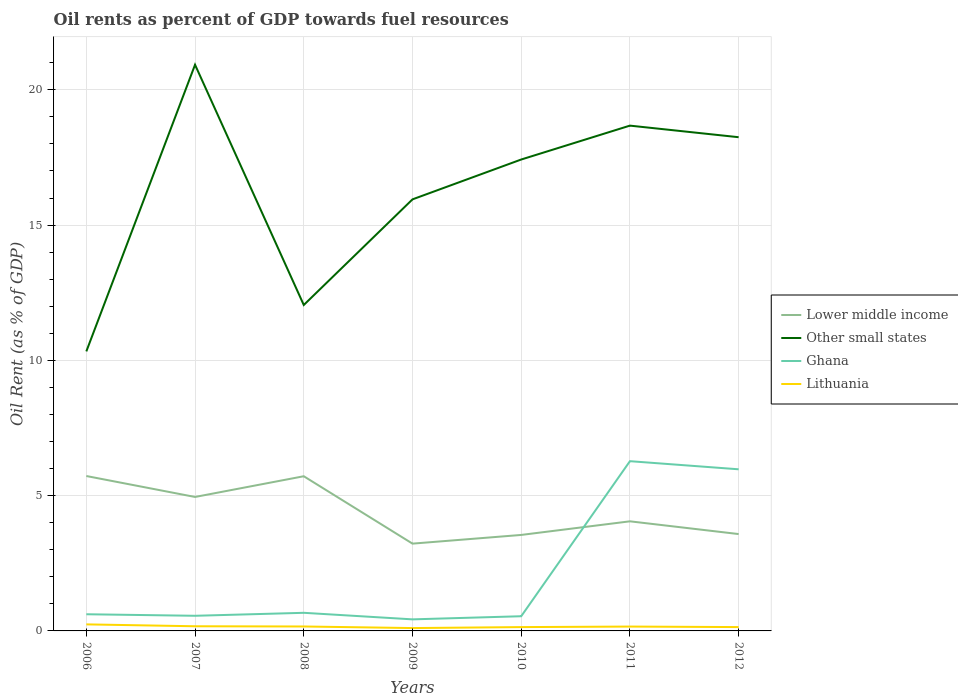Does the line corresponding to Lower middle income intersect with the line corresponding to Other small states?
Your response must be concise. No. Is the number of lines equal to the number of legend labels?
Keep it short and to the point. Yes. Across all years, what is the maximum oil rent in Other small states?
Your answer should be compact. 10.33. In which year was the oil rent in Other small states maximum?
Offer a very short reply. 2006. What is the total oil rent in Other small states in the graph?
Your response must be concise. 8.88. What is the difference between the highest and the second highest oil rent in Ghana?
Your response must be concise. 5.85. Is the oil rent in Lower middle income strictly greater than the oil rent in Ghana over the years?
Provide a succinct answer. No. How many lines are there?
Provide a succinct answer. 4. What is the difference between two consecutive major ticks on the Y-axis?
Offer a terse response. 5. Does the graph contain any zero values?
Provide a succinct answer. No. Where does the legend appear in the graph?
Your answer should be very brief. Center right. How many legend labels are there?
Your answer should be very brief. 4. What is the title of the graph?
Your response must be concise. Oil rents as percent of GDP towards fuel resources. What is the label or title of the X-axis?
Give a very brief answer. Years. What is the label or title of the Y-axis?
Ensure brevity in your answer.  Oil Rent (as % of GDP). What is the Oil Rent (as % of GDP) of Lower middle income in 2006?
Provide a short and direct response. 5.73. What is the Oil Rent (as % of GDP) of Other small states in 2006?
Keep it short and to the point. 10.33. What is the Oil Rent (as % of GDP) in Ghana in 2006?
Your response must be concise. 0.62. What is the Oil Rent (as % of GDP) of Lithuania in 2006?
Provide a succinct answer. 0.24. What is the Oil Rent (as % of GDP) of Lower middle income in 2007?
Make the answer very short. 4.95. What is the Oil Rent (as % of GDP) of Other small states in 2007?
Make the answer very short. 20.93. What is the Oil Rent (as % of GDP) in Ghana in 2007?
Make the answer very short. 0.56. What is the Oil Rent (as % of GDP) of Lithuania in 2007?
Your answer should be compact. 0.17. What is the Oil Rent (as % of GDP) of Lower middle income in 2008?
Offer a very short reply. 5.72. What is the Oil Rent (as % of GDP) in Other small states in 2008?
Ensure brevity in your answer.  12.05. What is the Oil Rent (as % of GDP) of Ghana in 2008?
Your response must be concise. 0.67. What is the Oil Rent (as % of GDP) in Lithuania in 2008?
Offer a terse response. 0.16. What is the Oil Rent (as % of GDP) in Lower middle income in 2009?
Provide a short and direct response. 3.23. What is the Oil Rent (as % of GDP) of Other small states in 2009?
Offer a very short reply. 15.95. What is the Oil Rent (as % of GDP) in Ghana in 2009?
Provide a short and direct response. 0.43. What is the Oil Rent (as % of GDP) in Lithuania in 2009?
Provide a short and direct response. 0.11. What is the Oil Rent (as % of GDP) in Lower middle income in 2010?
Make the answer very short. 3.55. What is the Oil Rent (as % of GDP) of Other small states in 2010?
Your response must be concise. 17.42. What is the Oil Rent (as % of GDP) of Ghana in 2010?
Your answer should be very brief. 0.54. What is the Oil Rent (as % of GDP) of Lithuania in 2010?
Offer a very short reply. 0.14. What is the Oil Rent (as % of GDP) of Lower middle income in 2011?
Offer a very short reply. 4.05. What is the Oil Rent (as % of GDP) in Other small states in 2011?
Give a very brief answer. 18.68. What is the Oil Rent (as % of GDP) in Ghana in 2011?
Provide a succinct answer. 6.27. What is the Oil Rent (as % of GDP) of Lithuania in 2011?
Give a very brief answer. 0.16. What is the Oil Rent (as % of GDP) in Lower middle income in 2012?
Your answer should be compact. 3.58. What is the Oil Rent (as % of GDP) in Other small states in 2012?
Make the answer very short. 18.25. What is the Oil Rent (as % of GDP) in Ghana in 2012?
Your answer should be compact. 5.97. What is the Oil Rent (as % of GDP) of Lithuania in 2012?
Your response must be concise. 0.14. Across all years, what is the maximum Oil Rent (as % of GDP) in Lower middle income?
Provide a short and direct response. 5.73. Across all years, what is the maximum Oil Rent (as % of GDP) in Other small states?
Make the answer very short. 20.93. Across all years, what is the maximum Oil Rent (as % of GDP) in Ghana?
Give a very brief answer. 6.27. Across all years, what is the maximum Oil Rent (as % of GDP) of Lithuania?
Your answer should be very brief. 0.24. Across all years, what is the minimum Oil Rent (as % of GDP) of Lower middle income?
Keep it short and to the point. 3.23. Across all years, what is the minimum Oil Rent (as % of GDP) in Other small states?
Ensure brevity in your answer.  10.33. Across all years, what is the minimum Oil Rent (as % of GDP) of Ghana?
Give a very brief answer. 0.43. Across all years, what is the minimum Oil Rent (as % of GDP) in Lithuania?
Provide a short and direct response. 0.11. What is the total Oil Rent (as % of GDP) of Lower middle income in the graph?
Your answer should be very brief. 30.8. What is the total Oil Rent (as % of GDP) in Other small states in the graph?
Your answer should be compact. 113.61. What is the total Oil Rent (as % of GDP) in Ghana in the graph?
Offer a very short reply. 15.06. What is the total Oil Rent (as % of GDP) in Lithuania in the graph?
Your answer should be compact. 1.13. What is the difference between the Oil Rent (as % of GDP) in Lower middle income in 2006 and that in 2007?
Give a very brief answer. 0.77. What is the difference between the Oil Rent (as % of GDP) in Other small states in 2006 and that in 2007?
Provide a succinct answer. -10.6. What is the difference between the Oil Rent (as % of GDP) in Ghana in 2006 and that in 2007?
Your response must be concise. 0.06. What is the difference between the Oil Rent (as % of GDP) of Lithuania in 2006 and that in 2007?
Offer a very short reply. 0.07. What is the difference between the Oil Rent (as % of GDP) in Lower middle income in 2006 and that in 2008?
Give a very brief answer. 0.01. What is the difference between the Oil Rent (as % of GDP) in Other small states in 2006 and that in 2008?
Provide a succinct answer. -1.72. What is the difference between the Oil Rent (as % of GDP) of Ghana in 2006 and that in 2008?
Make the answer very short. -0.05. What is the difference between the Oil Rent (as % of GDP) in Lithuania in 2006 and that in 2008?
Offer a very short reply. 0.08. What is the difference between the Oil Rent (as % of GDP) of Lower middle income in 2006 and that in 2009?
Provide a succinct answer. 2.5. What is the difference between the Oil Rent (as % of GDP) in Other small states in 2006 and that in 2009?
Your response must be concise. -5.62. What is the difference between the Oil Rent (as % of GDP) in Ghana in 2006 and that in 2009?
Your answer should be very brief. 0.19. What is the difference between the Oil Rent (as % of GDP) of Lithuania in 2006 and that in 2009?
Provide a succinct answer. 0.14. What is the difference between the Oil Rent (as % of GDP) in Lower middle income in 2006 and that in 2010?
Offer a very short reply. 2.18. What is the difference between the Oil Rent (as % of GDP) in Other small states in 2006 and that in 2010?
Provide a succinct answer. -7.09. What is the difference between the Oil Rent (as % of GDP) in Ghana in 2006 and that in 2010?
Keep it short and to the point. 0.07. What is the difference between the Oil Rent (as % of GDP) of Lithuania in 2006 and that in 2010?
Provide a succinct answer. 0.1. What is the difference between the Oil Rent (as % of GDP) of Lower middle income in 2006 and that in 2011?
Your answer should be compact. 1.67. What is the difference between the Oil Rent (as % of GDP) of Other small states in 2006 and that in 2011?
Give a very brief answer. -8.34. What is the difference between the Oil Rent (as % of GDP) in Ghana in 2006 and that in 2011?
Your answer should be very brief. -5.66. What is the difference between the Oil Rent (as % of GDP) of Lithuania in 2006 and that in 2011?
Give a very brief answer. 0.08. What is the difference between the Oil Rent (as % of GDP) in Lower middle income in 2006 and that in 2012?
Keep it short and to the point. 2.15. What is the difference between the Oil Rent (as % of GDP) in Other small states in 2006 and that in 2012?
Make the answer very short. -7.92. What is the difference between the Oil Rent (as % of GDP) in Ghana in 2006 and that in 2012?
Keep it short and to the point. -5.36. What is the difference between the Oil Rent (as % of GDP) of Lithuania in 2006 and that in 2012?
Provide a succinct answer. 0.1. What is the difference between the Oil Rent (as % of GDP) in Lower middle income in 2007 and that in 2008?
Your answer should be compact. -0.77. What is the difference between the Oil Rent (as % of GDP) in Other small states in 2007 and that in 2008?
Give a very brief answer. 8.88. What is the difference between the Oil Rent (as % of GDP) in Ghana in 2007 and that in 2008?
Keep it short and to the point. -0.11. What is the difference between the Oil Rent (as % of GDP) in Lithuania in 2007 and that in 2008?
Ensure brevity in your answer.  0.01. What is the difference between the Oil Rent (as % of GDP) of Lower middle income in 2007 and that in 2009?
Give a very brief answer. 1.73. What is the difference between the Oil Rent (as % of GDP) in Other small states in 2007 and that in 2009?
Offer a very short reply. 4.98. What is the difference between the Oil Rent (as % of GDP) of Ghana in 2007 and that in 2009?
Your response must be concise. 0.13. What is the difference between the Oil Rent (as % of GDP) in Lithuania in 2007 and that in 2009?
Your response must be concise. 0.07. What is the difference between the Oil Rent (as % of GDP) in Lower middle income in 2007 and that in 2010?
Offer a terse response. 1.4. What is the difference between the Oil Rent (as % of GDP) in Other small states in 2007 and that in 2010?
Provide a succinct answer. 3.5. What is the difference between the Oil Rent (as % of GDP) of Ghana in 2007 and that in 2010?
Keep it short and to the point. 0.02. What is the difference between the Oil Rent (as % of GDP) in Lithuania in 2007 and that in 2010?
Provide a short and direct response. 0.03. What is the difference between the Oil Rent (as % of GDP) of Lower middle income in 2007 and that in 2011?
Provide a short and direct response. 0.9. What is the difference between the Oil Rent (as % of GDP) of Other small states in 2007 and that in 2011?
Offer a terse response. 2.25. What is the difference between the Oil Rent (as % of GDP) of Ghana in 2007 and that in 2011?
Give a very brief answer. -5.71. What is the difference between the Oil Rent (as % of GDP) in Lithuania in 2007 and that in 2011?
Provide a short and direct response. 0.01. What is the difference between the Oil Rent (as % of GDP) in Lower middle income in 2007 and that in 2012?
Your response must be concise. 1.37. What is the difference between the Oil Rent (as % of GDP) of Other small states in 2007 and that in 2012?
Your response must be concise. 2.68. What is the difference between the Oil Rent (as % of GDP) in Ghana in 2007 and that in 2012?
Your response must be concise. -5.41. What is the difference between the Oil Rent (as % of GDP) in Lithuania in 2007 and that in 2012?
Give a very brief answer. 0.03. What is the difference between the Oil Rent (as % of GDP) of Lower middle income in 2008 and that in 2009?
Make the answer very short. 2.49. What is the difference between the Oil Rent (as % of GDP) of Other small states in 2008 and that in 2009?
Keep it short and to the point. -3.9. What is the difference between the Oil Rent (as % of GDP) in Ghana in 2008 and that in 2009?
Your answer should be compact. 0.24. What is the difference between the Oil Rent (as % of GDP) in Lithuania in 2008 and that in 2009?
Make the answer very short. 0.06. What is the difference between the Oil Rent (as % of GDP) in Lower middle income in 2008 and that in 2010?
Keep it short and to the point. 2.17. What is the difference between the Oil Rent (as % of GDP) in Other small states in 2008 and that in 2010?
Provide a short and direct response. -5.38. What is the difference between the Oil Rent (as % of GDP) of Ghana in 2008 and that in 2010?
Provide a short and direct response. 0.13. What is the difference between the Oil Rent (as % of GDP) in Lithuania in 2008 and that in 2010?
Give a very brief answer. 0.02. What is the difference between the Oil Rent (as % of GDP) in Lower middle income in 2008 and that in 2011?
Provide a succinct answer. 1.67. What is the difference between the Oil Rent (as % of GDP) in Other small states in 2008 and that in 2011?
Your answer should be compact. -6.63. What is the difference between the Oil Rent (as % of GDP) of Ghana in 2008 and that in 2011?
Provide a short and direct response. -5.6. What is the difference between the Oil Rent (as % of GDP) of Lithuania in 2008 and that in 2011?
Your answer should be very brief. 0. What is the difference between the Oil Rent (as % of GDP) of Lower middle income in 2008 and that in 2012?
Provide a succinct answer. 2.14. What is the difference between the Oil Rent (as % of GDP) of Other small states in 2008 and that in 2012?
Give a very brief answer. -6.2. What is the difference between the Oil Rent (as % of GDP) of Ghana in 2008 and that in 2012?
Keep it short and to the point. -5.3. What is the difference between the Oil Rent (as % of GDP) in Lithuania in 2008 and that in 2012?
Provide a short and direct response. 0.02. What is the difference between the Oil Rent (as % of GDP) in Lower middle income in 2009 and that in 2010?
Provide a short and direct response. -0.32. What is the difference between the Oil Rent (as % of GDP) in Other small states in 2009 and that in 2010?
Give a very brief answer. -1.47. What is the difference between the Oil Rent (as % of GDP) of Ghana in 2009 and that in 2010?
Your answer should be compact. -0.12. What is the difference between the Oil Rent (as % of GDP) in Lithuania in 2009 and that in 2010?
Provide a short and direct response. -0.04. What is the difference between the Oil Rent (as % of GDP) in Lower middle income in 2009 and that in 2011?
Make the answer very short. -0.82. What is the difference between the Oil Rent (as % of GDP) of Other small states in 2009 and that in 2011?
Ensure brevity in your answer.  -2.73. What is the difference between the Oil Rent (as % of GDP) of Ghana in 2009 and that in 2011?
Your answer should be very brief. -5.85. What is the difference between the Oil Rent (as % of GDP) in Lithuania in 2009 and that in 2011?
Provide a succinct answer. -0.06. What is the difference between the Oil Rent (as % of GDP) in Lower middle income in 2009 and that in 2012?
Ensure brevity in your answer.  -0.35. What is the difference between the Oil Rent (as % of GDP) in Other small states in 2009 and that in 2012?
Make the answer very short. -2.3. What is the difference between the Oil Rent (as % of GDP) of Ghana in 2009 and that in 2012?
Offer a very short reply. -5.55. What is the difference between the Oil Rent (as % of GDP) of Lithuania in 2009 and that in 2012?
Your answer should be very brief. -0.04. What is the difference between the Oil Rent (as % of GDP) in Lower middle income in 2010 and that in 2011?
Make the answer very short. -0.5. What is the difference between the Oil Rent (as % of GDP) in Other small states in 2010 and that in 2011?
Keep it short and to the point. -1.25. What is the difference between the Oil Rent (as % of GDP) of Ghana in 2010 and that in 2011?
Keep it short and to the point. -5.73. What is the difference between the Oil Rent (as % of GDP) of Lithuania in 2010 and that in 2011?
Your answer should be compact. -0.02. What is the difference between the Oil Rent (as % of GDP) of Lower middle income in 2010 and that in 2012?
Your answer should be very brief. -0.03. What is the difference between the Oil Rent (as % of GDP) of Other small states in 2010 and that in 2012?
Your answer should be compact. -0.82. What is the difference between the Oil Rent (as % of GDP) of Ghana in 2010 and that in 2012?
Offer a terse response. -5.43. What is the difference between the Oil Rent (as % of GDP) of Lithuania in 2010 and that in 2012?
Offer a terse response. -0. What is the difference between the Oil Rent (as % of GDP) of Lower middle income in 2011 and that in 2012?
Provide a short and direct response. 0.47. What is the difference between the Oil Rent (as % of GDP) in Other small states in 2011 and that in 2012?
Make the answer very short. 0.43. What is the difference between the Oil Rent (as % of GDP) in Lithuania in 2011 and that in 2012?
Give a very brief answer. 0.02. What is the difference between the Oil Rent (as % of GDP) of Lower middle income in 2006 and the Oil Rent (as % of GDP) of Other small states in 2007?
Your response must be concise. -15.2. What is the difference between the Oil Rent (as % of GDP) in Lower middle income in 2006 and the Oil Rent (as % of GDP) in Ghana in 2007?
Your answer should be compact. 5.17. What is the difference between the Oil Rent (as % of GDP) of Lower middle income in 2006 and the Oil Rent (as % of GDP) of Lithuania in 2007?
Give a very brief answer. 5.55. What is the difference between the Oil Rent (as % of GDP) in Other small states in 2006 and the Oil Rent (as % of GDP) in Ghana in 2007?
Provide a short and direct response. 9.77. What is the difference between the Oil Rent (as % of GDP) in Other small states in 2006 and the Oil Rent (as % of GDP) in Lithuania in 2007?
Give a very brief answer. 10.16. What is the difference between the Oil Rent (as % of GDP) in Ghana in 2006 and the Oil Rent (as % of GDP) in Lithuania in 2007?
Your answer should be compact. 0.44. What is the difference between the Oil Rent (as % of GDP) in Lower middle income in 2006 and the Oil Rent (as % of GDP) in Other small states in 2008?
Give a very brief answer. -6.32. What is the difference between the Oil Rent (as % of GDP) in Lower middle income in 2006 and the Oil Rent (as % of GDP) in Ghana in 2008?
Your answer should be compact. 5.06. What is the difference between the Oil Rent (as % of GDP) in Lower middle income in 2006 and the Oil Rent (as % of GDP) in Lithuania in 2008?
Your answer should be compact. 5.56. What is the difference between the Oil Rent (as % of GDP) of Other small states in 2006 and the Oil Rent (as % of GDP) of Ghana in 2008?
Offer a terse response. 9.66. What is the difference between the Oil Rent (as % of GDP) of Other small states in 2006 and the Oil Rent (as % of GDP) of Lithuania in 2008?
Your answer should be compact. 10.17. What is the difference between the Oil Rent (as % of GDP) in Ghana in 2006 and the Oil Rent (as % of GDP) in Lithuania in 2008?
Give a very brief answer. 0.45. What is the difference between the Oil Rent (as % of GDP) in Lower middle income in 2006 and the Oil Rent (as % of GDP) in Other small states in 2009?
Your response must be concise. -10.23. What is the difference between the Oil Rent (as % of GDP) in Lower middle income in 2006 and the Oil Rent (as % of GDP) in Ghana in 2009?
Your response must be concise. 5.3. What is the difference between the Oil Rent (as % of GDP) in Lower middle income in 2006 and the Oil Rent (as % of GDP) in Lithuania in 2009?
Your answer should be very brief. 5.62. What is the difference between the Oil Rent (as % of GDP) of Other small states in 2006 and the Oil Rent (as % of GDP) of Ghana in 2009?
Ensure brevity in your answer.  9.9. What is the difference between the Oil Rent (as % of GDP) in Other small states in 2006 and the Oil Rent (as % of GDP) in Lithuania in 2009?
Provide a short and direct response. 10.23. What is the difference between the Oil Rent (as % of GDP) in Ghana in 2006 and the Oil Rent (as % of GDP) in Lithuania in 2009?
Keep it short and to the point. 0.51. What is the difference between the Oil Rent (as % of GDP) of Lower middle income in 2006 and the Oil Rent (as % of GDP) of Other small states in 2010?
Ensure brevity in your answer.  -11.7. What is the difference between the Oil Rent (as % of GDP) of Lower middle income in 2006 and the Oil Rent (as % of GDP) of Ghana in 2010?
Provide a short and direct response. 5.18. What is the difference between the Oil Rent (as % of GDP) in Lower middle income in 2006 and the Oil Rent (as % of GDP) in Lithuania in 2010?
Ensure brevity in your answer.  5.58. What is the difference between the Oil Rent (as % of GDP) of Other small states in 2006 and the Oil Rent (as % of GDP) of Ghana in 2010?
Your answer should be compact. 9.79. What is the difference between the Oil Rent (as % of GDP) of Other small states in 2006 and the Oil Rent (as % of GDP) of Lithuania in 2010?
Your response must be concise. 10.19. What is the difference between the Oil Rent (as % of GDP) in Ghana in 2006 and the Oil Rent (as % of GDP) in Lithuania in 2010?
Your response must be concise. 0.47. What is the difference between the Oil Rent (as % of GDP) of Lower middle income in 2006 and the Oil Rent (as % of GDP) of Other small states in 2011?
Give a very brief answer. -12.95. What is the difference between the Oil Rent (as % of GDP) of Lower middle income in 2006 and the Oil Rent (as % of GDP) of Ghana in 2011?
Give a very brief answer. -0.55. What is the difference between the Oil Rent (as % of GDP) in Lower middle income in 2006 and the Oil Rent (as % of GDP) in Lithuania in 2011?
Provide a succinct answer. 5.56. What is the difference between the Oil Rent (as % of GDP) in Other small states in 2006 and the Oil Rent (as % of GDP) in Ghana in 2011?
Give a very brief answer. 4.06. What is the difference between the Oil Rent (as % of GDP) of Other small states in 2006 and the Oil Rent (as % of GDP) of Lithuania in 2011?
Your response must be concise. 10.17. What is the difference between the Oil Rent (as % of GDP) of Ghana in 2006 and the Oil Rent (as % of GDP) of Lithuania in 2011?
Ensure brevity in your answer.  0.46. What is the difference between the Oil Rent (as % of GDP) of Lower middle income in 2006 and the Oil Rent (as % of GDP) of Other small states in 2012?
Give a very brief answer. -12.52. What is the difference between the Oil Rent (as % of GDP) of Lower middle income in 2006 and the Oil Rent (as % of GDP) of Ghana in 2012?
Provide a short and direct response. -0.25. What is the difference between the Oil Rent (as % of GDP) of Lower middle income in 2006 and the Oil Rent (as % of GDP) of Lithuania in 2012?
Provide a short and direct response. 5.58. What is the difference between the Oil Rent (as % of GDP) of Other small states in 2006 and the Oil Rent (as % of GDP) of Ghana in 2012?
Make the answer very short. 4.36. What is the difference between the Oil Rent (as % of GDP) in Other small states in 2006 and the Oil Rent (as % of GDP) in Lithuania in 2012?
Ensure brevity in your answer.  10.19. What is the difference between the Oil Rent (as % of GDP) in Ghana in 2006 and the Oil Rent (as % of GDP) in Lithuania in 2012?
Your response must be concise. 0.47. What is the difference between the Oil Rent (as % of GDP) of Lower middle income in 2007 and the Oil Rent (as % of GDP) of Other small states in 2008?
Give a very brief answer. -7.1. What is the difference between the Oil Rent (as % of GDP) of Lower middle income in 2007 and the Oil Rent (as % of GDP) of Ghana in 2008?
Ensure brevity in your answer.  4.28. What is the difference between the Oil Rent (as % of GDP) in Lower middle income in 2007 and the Oil Rent (as % of GDP) in Lithuania in 2008?
Give a very brief answer. 4.79. What is the difference between the Oil Rent (as % of GDP) of Other small states in 2007 and the Oil Rent (as % of GDP) of Ghana in 2008?
Give a very brief answer. 20.26. What is the difference between the Oil Rent (as % of GDP) in Other small states in 2007 and the Oil Rent (as % of GDP) in Lithuania in 2008?
Provide a short and direct response. 20.76. What is the difference between the Oil Rent (as % of GDP) of Ghana in 2007 and the Oil Rent (as % of GDP) of Lithuania in 2008?
Provide a short and direct response. 0.4. What is the difference between the Oil Rent (as % of GDP) of Lower middle income in 2007 and the Oil Rent (as % of GDP) of Ghana in 2009?
Make the answer very short. 4.52. What is the difference between the Oil Rent (as % of GDP) in Lower middle income in 2007 and the Oil Rent (as % of GDP) in Lithuania in 2009?
Offer a very short reply. 4.85. What is the difference between the Oil Rent (as % of GDP) of Other small states in 2007 and the Oil Rent (as % of GDP) of Ghana in 2009?
Offer a very short reply. 20.5. What is the difference between the Oil Rent (as % of GDP) of Other small states in 2007 and the Oil Rent (as % of GDP) of Lithuania in 2009?
Provide a succinct answer. 20.82. What is the difference between the Oil Rent (as % of GDP) in Ghana in 2007 and the Oil Rent (as % of GDP) in Lithuania in 2009?
Provide a short and direct response. 0.45. What is the difference between the Oil Rent (as % of GDP) of Lower middle income in 2007 and the Oil Rent (as % of GDP) of Other small states in 2010?
Your response must be concise. -12.47. What is the difference between the Oil Rent (as % of GDP) in Lower middle income in 2007 and the Oil Rent (as % of GDP) in Ghana in 2010?
Ensure brevity in your answer.  4.41. What is the difference between the Oil Rent (as % of GDP) of Lower middle income in 2007 and the Oil Rent (as % of GDP) of Lithuania in 2010?
Provide a succinct answer. 4.81. What is the difference between the Oil Rent (as % of GDP) of Other small states in 2007 and the Oil Rent (as % of GDP) of Ghana in 2010?
Keep it short and to the point. 20.38. What is the difference between the Oil Rent (as % of GDP) in Other small states in 2007 and the Oil Rent (as % of GDP) in Lithuania in 2010?
Make the answer very short. 20.79. What is the difference between the Oil Rent (as % of GDP) in Ghana in 2007 and the Oil Rent (as % of GDP) in Lithuania in 2010?
Give a very brief answer. 0.42. What is the difference between the Oil Rent (as % of GDP) of Lower middle income in 2007 and the Oil Rent (as % of GDP) of Other small states in 2011?
Provide a short and direct response. -13.73. What is the difference between the Oil Rent (as % of GDP) in Lower middle income in 2007 and the Oil Rent (as % of GDP) in Ghana in 2011?
Offer a very short reply. -1.32. What is the difference between the Oil Rent (as % of GDP) in Lower middle income in 2007 and the Oil Rent (as % of GDP) in Lithuania in 2011?
Provide a succinct answer. 4.79. What is the difference between the Oil Rent (as % of GDP) of Other small states in 2007 and the Oil Rent (as % of GDP) of Ghana in 2011?
Provide a succinct answer. 14.65. What is the difference between the Oil Rent (as % of GDP) in Other small states in 2007 and the Oil Rent (as % of GDP) in Lithuania in 2011?
Provide a short and direct response. 20.77. What is the difference between the Oil Rent (as % of GDP) of Ghana in 2007 and the Oil Rent (as % of GDP) of Lithuania in 2011?
Your answer should be compact. 0.4. What is the difference between the Oil Rent (as % of GDP) of Lower middle income in 2007 and the Oil Rent (as % of GDP) of Other small states in 2012?
Your answer should be compact. -13.3. What is the difference between the Oil Rent (as % of GDP) of Lower middle income in 2007 and the Oil Rent (as % of GDP) of Ghana in 2012?
Offer a very short reply. -1.02. What is the difference between the Oil Rent (as % of GDP) of Lower middle income in 2007 and the Oil Rent (as % of GDP) of Lithuania in 2012?
Offer a very short reply. 4.81. What is the difference between the Oil Rent (as % of GDP) in Other small states in 2007 and the Oil Rent (as % of GDP) in Ghana in 2012?
Provide a short and direct response. 14.95. What is the difference between the Oil Rent (as % of GDP) in Other small states in 2007 and the Oil Rent (as % of GDP) in Lithuania in 2012?
Your answer should be compact. 20.79. What is the difference between the Oil Rent (as % of GDP) of Ghana in 2007 and the Oil Rent (as % of GDP) of Lithuania in 2012?
Make the answer very short. 0.42. What is the difference between the Oil Rent (as % of GDP) in Lower middle income in 2008 and the Oil Rent (as % of GDP) in Other small states in 2009?
Offer a terse response. -10.23. What is the difference between the Oil Rent (as % of GDP) in Lower middle income in 2008 and the Oil Rent (as % of GDP) in Ghana in 2009?
Ensure brevity in your answer.  5.29. What is the difference between the Oil Rent (as % of GDP) of Lower middle income in 2008 and the Oil Rent (as % of GDP) of Lithuania in 2009?
Offer a terse response. 5.61. What is the difference between the Oil Rent (as % of GDP) in Other small states in 2008 and the Oil Rent (as % of GDP) in Ghana in 2009?
Provide a succinct answer. 11.62. What is the difference between the Oil Rent (as % of GDP) of Other small states in 2008 and the Oil Rent (as % of GDP) of Lithuania in 2009?
Make the answer very short. 11.94. What is the difference between the Oil Rent (as % of GDP) in Ghana in 2008 and the Oil Rent (as % of GDP) in Lithuania in 2009?
Make the answer very short. 0.56. What is the difference between the Oil Rent (as % of GDP) in Lower middle income in 2008 and the Oil Rent (as % of GDP) in Other small states in 2010?
Provide a short and direct response. -11.71. What is the difference between the Oil Rent (as % of GDP) of Lower middle income in 2008 and the Oil Rent (as % of GDP) of Ghana in 2010?
Keep it short and to the point. 5.17. What is the difference between the Oil Rent (as % of GDP) in Lower middle income in 2008 and the Oil Rent (as % of GDP) in Lithuania in 2010?
Provide a short and direct response. 5.58. What is the difference between the Oil Rent (as % of GDP) of Other small states in 2008 and the Oil Rent (as % of GDP) of Ghana in 2010?
Your answer should be very brief. 11.5. What is the difference between the Oil Rent (as % of GDP) in Other small states in 2008 and the Oil Rent (as % of GDP) in Lithuania in 2010?
Keep it short and to the point. 11.91. What is the difference between the Oil Rent (as % of GDP) of Ghana in 2008 and the Oil Rent (as % of GDP) of Lithuania in 2010?
Your answer should be very brief. 0.53. What is the difference between the Oil Rent (as % of GDP) of Lower middle income in 2008 and the Oil Rent (as % of GDP) of Other small states in 2011?
Your answer should be very brief. -12.96. What is the difference between the Oil Rent (as % of GDP) of Lower middle income in 2008 and the Oil Rent (as % of GDP) of Ghana in 2011?
Provide a succinct answer. -0.56. What is the difference between the Oil Rent (as % of GDP) in Lower middle income in 2008 and the Oil Rent (as % of GDP) in Lithuania in 2011?
Ensure brevity in your answer.  5.56. What is the difference between the Oil Rent (as % of GDP) of Other small states in 2008 and the Oil Rent (as % of GDP) of Ghana in 2011?
Make the answer very short. 5.77. What is the difference between the Oil Rent (as % of GDP) of Other small states in 2008 and the Oil Rent (as % of GDP) of Lithuania in 2011?
Provide a succinct answer. 11.89. What is the difference between the Oil Rent (as % of GDP) in Ghana in 2008 and the Oil Rent (as % of GDP) in Lithuania in 2011?
Give a very brief answer. 0.51. What is the difference between the Oil Rent (as % of GDP) of Lower middle income in 2008 and the Oil Rent (as % of GDP) of Other small states in 2012?
Your answer should be very brief. -12.53. What is the difference between the Oil Rent (as % of GDP) of Lower middle income in 2008 and the Oil Rent (as % of GDP) of Ghana in 2012?
Offer a very short reply. -0.26. What is the difference between the Oil Rent (as % of GDP) of Lower middle income in 2008 and the Oil Rent (as % of GDP) of Lithuania in 2012?
Provide a succinct answer. 5.58. What is the difference between the Oil Rent (as % of GDP) of Other small states in 2008 and the Oil Rent (as % of GDP) of Ghana in 2012?
Your response must be concise. 6.07. What is the difference between the Oil Rent (as % of GDP) in Other small states in 2008 and the Oil Rent (as % of GDP) in Lithuania in 2012?
Provide a short and direct response. 11.9. What is the difference between the Oil Rent (as % of GDP) of Ghana in 2008 and the Oil Rent (as % of GDP) of Lithuania in 2012?
Your answer should be very brief. 0.53. What is the difference between the Oil Rent (as % of GDP) in Lower middle income in 2009 and the Oil Rent (as % of GDP) in Other small states in 2010?
Keep it short and to the point. -14.2. What is the difference between the Oil Rent (as % of GDP) of Lower middle income in 2009 and the Oil Rent (as % of GDP) of Ghana in 2010?
Give a very brief answer. 2.68. What is the difference between the Oil Rent (as % of GDP) of Lower middle income in 2009 and the Oil Rent (as % of GDP) of Lithuania in 2010?
Your answer should be very brief. 3.08. What is the difference between the Oil Rent (as % of GDP) of Other small states in 2009 and the Oil Rent (as % of GDP) of Ghana in 2010?
Offer a very short reply. 15.41. What is the difference between the Oil Rent (as % of GDP) of Other small states in 2009 and the Oil Rent (as % of GDP) of Lithuania in 2010?
Your answer should be compact. 15.81. What is the difference between the Oil Rent (as % of GDP) of Ghana in 2009 and the Oil Rent (as % of GDP) of Lithuania in 2010?
Offer a very short reply. 0.29. What is the difference between the Oil Rent (as % of GDP) in Lower middle income in 2009 and the Oil Rent (as % of GDP) in Other small states in 2011?
Ensure brevity in your answer.  -15.45. What is the difference between the Oil Rent (as % of GDP) of Lower middle income in 2009 and the Oil Rent (as % of GDP) of Ghana in 2011?
Offer a terse response. -3.05. What is the difference between the Oil Rent (as % of GDP) in Lower middle income in 2009 and the Oil Rent (as % of GDP) in Lithuania in 2011?
Your answer should be compact. 3.07. What is the difference between the Oil Rent (as % of GDP) of Other small states in 2009 and the Oil Rent (as % of GDP) of Ghana in 2011?
Keep it short and to the point. 9.68. What is the difference between the Oil Rent (as % of GDP) in Other small states in 2009 and the Oil Rent (as % of GDP) in Lithuania in 2011?
Your answer should be compact. 15.79. What is the difference between the Oil Rent (as % of GDP) of Ghana in 2009 and the Oil Rent (as % of GDP) of Lithuania in 2011?
Your response must be concise. 0.27. What is the difference between the Oil Rent (as % of GDP) of Lower middle income in 2009 and the Oil Rent (as % of GDP) of Other small states in 2012?
Give a very brief answer. -15.02. What is the difference between the Oil Rent (as % of GDP) in Lower middle income in 2009 and the Oil Rent (as % of GDP) in Ghana in 2012?
Your answer should be compact. -2.75. What is the difference between the Oil Rent (as % of GDP) of Lower middle income in 2009 and the Oil Rent (as % of GDP) of Lithuania in 2012?
Your answer should be compact. 3.08. What is the difference between the Oil Rent (as % of GDP) of Other small states in 2009 and the Oil Rent (as % of GDP) of Ghana in 2012?
Give a very brief answer. 9.98. What is the difference between the Oil Rent (as % of GDP) of Other small states in 2009 and the Oil Rent (as % of GDP) of Lithuania in 2012?
Give a very brief answer. 15.81. What is the difference between the Oil Rent (as % of GDP) of Ghana in 2009 and the Oil Rent (as % of GDP) of Lithuania in 2012?
Provide a short and direct response. 0.28. What is the difference between the Oil Rent (as % of GDP) of Lower middle income in 2010 and the Oil Rent (as % of GDP) of Other small states in 2011?
Provide a succinct answer. -15.13. What is the difference between the Oil Rent (as % of GDP) in Lower middle income in 2010 and the Oil Rent (as % of GDP) in Ghana in 2011?
Give a very brief answer. -2.73. What is the difference between the Oil Rent (as % of GDP) of Lower middle income in 2010 and the Oil Rent (as % of GDP) of Lithuania in 2011?
Your answer should be compact. 3.39. What is the difference between the Oil Rent (as % of GDP) of Other small states in 2010 and the Oil Rent (as % of GDP) of Ghana in 2011?
Your answer should be compact. 11.15. What is the difference between the Oil Rent (as % of GDP) in Other small states in 2010 and the Oil Rent (as % of GDP) in Lithuania in 2011?
Your answer should be very brief. 17.26. What is the difference between the Oil Rent (as % of GDP) in Ghana in 2010 and the Oil Rent (as % of GDP) in Lithuania in 2011?
Your answer should be compact. 0.38. What is the difference between the Oil Rent (as % of GDP) in Lower middle income in 2010 and the Oil Rent (as % of GDP) in Other small states in 2012?
Provide a short and direct response. -14.7. What is the difference between the Oil Rent (as % of GDP) in Lower middle income in 2010 and the Oil Rent (as % of GDP) in Ghana in 2012?
Give a very brief answer. -2.43. What is the difference between the Oil Rent (as % of GDP) of Lower middle income in 2010 and the Oil Rent (as % of GDP) of Lithuania in 2012?
Your response must be concise. 3.41. What is the difference between the Oil Rent (as % of GDP) in Other small states in 2010 and the Oil Rent (as % of GDP) in Ghana in 2012?
Your answer should be very brief. 11.45. What is the difference between the Oil Rent (as % of GDP) of Other small states in 2010 and the Oil Rent (as % of GDP) of Lithuania in 2012?
Give a very brief answer. 17.28. What is the difference between the Oil Rent (as % of GDP) of Ghana in 2010 and the Oil Rent (as % of GDP) of Lithuania in 2012?
Your answer should be compact. 0.4. What is the difference between the Oil Rent (as % of GDP) in Lower middle income in 2011 and the Oil Rent (as % of GDP) in Other small states in 2012?
Your response must be concise. -14.2. What is the difference between the Oil Rent (as % of GDP) in Lower middle income in 2011 and the Oil Rent (as % of GDP) in Ghana in 2012?
Offer a terse response. -1.92. What is the difference between the Oil Rent (as % of GDP) of Lower middle income in 2011 and the Oil Rent (as % of GDP) of Lithuania in 2012?
Your answer should be compact. 3.91. What is the difference between the Oil Rent (as % of GDP) of Other small states in 2011 and the Oil Rent (as % of GDP) of Ghana in 2012?
Provide a succinct answer. 12.7. What is the difference between the Oil Rent (as % of GDP) of Other small states in 2011 and the Oil Rent (as % of GDP) of Lithuania in 2012?
Your answer should be very brief. 18.53. What is the difference between the Oil Rent (as % of GDP) of Ghana in 2011 and the Oil Rent (as % of GDP) of Lithuania in 2012?
Offer a terse response. 6.13. What is the average Oil Rent (as % of GDP) in Lower middle income per year?
Make the answer very short. 4.4. What is the average Oil Rent (as % of GDP) of Other small states per year?
Your answer should be compact. 16.23. What is the average Oil Rent (as % of GDP) of Ghana per year?
Your response must be concise. 2.15. What is the average Oil Rent (as % of GDP) in Lithuania per year?
Ensure brevity in your answer.  0.16. In the year 2006, what is the difference between the Oil Rent (as % of GDP) in Lower middle income and Oil Rent (as % of GDP) in Other small states?
Ensure brevity in your answer.  -4.61. In the year 2006, what is the difference between the Oil Rent (as % of GDP) of Lower middle income and Oil Rent (as % of GDP) of Ghana?
Give a very brief answer. 5.11. In the year 2006, what is the difference between the Oil Rent (as % of GDP) of Lower middle income and Oil Rent (as % of GDP) of Lithuania?
Make the answer very short. 5.48. In the year 2006, what is the difference between the Oil Rent (as % of GDP) of Other small states and Oil Rent (as % of GDP) of Ghana?
Your answer should be compact. 9.72. In the year 2006, what is the difference between the Oil Rent (as % of GDP) of Other small states and Oil Rent (as % of GDP) of Lithuania?
Provide a short and direct response. 10.09. In the year 2006, what is the difference between the Oil Rent (as % of GDP) of Ghana and Oil Rent (as % of GDP) of Lithuania?
Offer a terse response. 0.37. In the year 2007, what is the difference between the Oil Rent (as % of GDP) of Lower middle income and Oil Rent (as % of GDP) of Other small states?
Your answer should be compact. -15.98. In the year 2007, what is the difference between the Oil Rent (as % of GDP) in Lower middle income and Oil Rent (as % of GDP) in Ghana?
Provide a short and direct response. 4.39. In the year 2007, what is the difference between the Oil Rent (as % of GDP) of Lower middle income and Oil Rent (as % of GDP) of Lithuania?
Offer a very short reply. 4.78. In the year 2007, what is the difference between the Oil Rent (as % of GDP) of Other small states and Oil Rent (as % of GDP) of Ghana?
Your answer should be very brief. 20.37. In the year 2007, what is the difference between the Oil Rent (as % of GDP) of Other small states and Oil Rent (as % of GDP) of Lithuania?
Make the answer very short. 20.76. In the year 2007, what is the difference between the Oil Rent (as % of GDP) in Ghana and Oil Rent (as % of GDP) in Lithuania?
Provide a succinct answer. 0.39. In the year 2008, what is the difference between the Oil Rent (as % of GDP) in Lower middle income and Oil Rent (as % of GDP) in Other small states?
Keep it short and to the point. -6.33. In the year 2008, what is the difference between the Oil Rent (as % of GDP) in Lower middle income and Oil Rent (as % of GDP) in Ghana?
Your answer should be compact. 5.05. In the year 2008, what is the difference between the Oil Rent (as % of GDP) in Lower middle income and Oil Rent (as % of GDP) in Lithuania?
Make the answer very short. 5.55. In the year 2008, what is the difference between the Oil Rent (as % of GDP) in Other small states and Oil Rent (as % of GDP) in Ghana?
Make the answer very short. 11.38. In the year 2008, what is the difference between the Oil Rent (as % of GDP) in Other small states and Oil Rent (as % of GDP) in Lithuania?
Provide a succinct answer. 11.88. In the year 2008, what is the difference between the Oil Rent (as % of GDP) of Ghana and Oil Rent (as % of GDP) of Lithuania?
Your answer should be very brief. 0.51. In the year 2009, what is the difference between the Oil Rent (as % of GDP) in Lower middle income and Oil Rent (as % of GDP) in Other small states?
Provide a short and direct response. -12.72. In the year 2009, what is the difference between the Oil Rent (as % of GDP) of Lower middle income and Oil Rent (as % of GDP) of Ghana?
Offer a terse response. 2.8. In the year 2009, what is the difference between the Oil Rent (as % of GDP) of Lower middle income and Oil Rent (as % of GDP) of Lithuania?
Your answer should be very brief. 3.12. In the year 2009, what is the difference between the Oil Rent (as % of GDP) in Other small states and Oil Rent (as % of GDP) in Ghana?
Provide a succinct answer. 15.52. In the year 2009, what is the difference between the Oil Rent (as % of GDP) in Other small states and Oil Rent (as % of GDP) in Lithuania?
Ensure brevity in your answer.  15.85. In the year 2009, what is the difference between the Oil Rent (as % of GDP) of Ghana and Oil Rent (as % of GDP) of Lithuania?
Provide a short and direct response. 0.32. In the year 2010, what is the difference between the Oil Rent (as % of GDP) in Lower middle income and Oil Rent (as % of GDP) in Other small states?
Make the answer very short. -13.88. In the year 2010, what is the difference between the Oil Rent (as % of GDP) of Lower middle income and Oil Rent (as % of GDP) of Ghana?
Make the answer very short. 3. In the year 2010, what is the difference between the Oil Rent (as % of GDP) of Lower middle income and Oil Rent (as % of GDP) of Lithuania?
Make the answer very short. 3.41. In the year 2010, what is the difference between the Oil Rent (as % of GDP) of Other small states and Oil Rent (as % of GDP) of Ghana?
Your answer should be very brief. 16.88. In the year 2010, what is the difference between the Oil Rent (as % of GDP) of Other small states and Oil Rent (as % of GDP) of Lithuania?
Offer a very short reply. 17.28. In the year 2010, what is the difference between the Oil Rent (as % of GDP) in Ghana and Oil Rent (as % of GDP) in Lithuania?
Offer a very short reply. 0.4. In the year 2011, what is the difference between the Oil Rent (as % of GDP) in Lower middle income and Oil Rent (as % of GDP) in Other small states?
Offer a terse response. -14.63. In the year 2011, what is the difference between the Oil Rent (as % of GDP) in Lower middle income and Oil Rent (as % of GDP) in Ghana?
Provide a short and direct response. -2.22. In the year 2011, what is the difference between the Oil Rent (as % of GDP) in Lower middle income and Oil Rent (as % of GDP) in Lithuania?
Make the answer very short. 3.89. In the year 2011, what is the difference between the Oil Rent (as % of GDP) in Other small states and Oil Rent (as % of GDP) in Ghana?
Your answer should be compact. 12.4. In the year 2011, what is the difference between the Oil Rent (as % of GDP) in Other small states and Oil Rent (as % of GDP) in Lithuania?
Provide a succinct answer. 18.52. In the year 2011, what is the difference between the Oil Rent (as % of GDP) of Ghana and Oil Rent (as % of GDP) of Lithuania?
Your answer should be very brief. 6.11. In the year 2012, what is the difference between the Oil Rent (as % of GDP) of Lower middle income and Oil Rent (as % of GDP) of Other small states?
Your answer should be compact. -14.67. In the year 2012, what is the difference between the Oil Rent (as % of GDP) in Lower middle income and Oil Rent (as % of GDP) in Ghana?
Offer a terse response. -2.39. In the year 2012, what is the difference between the Oil Rent (as % of GDP) of Lower middle income and Oil Rent (as % of GDP) of Lithuania?
Ensure brevity in your answer.  3.44. In the year 2012, what is the difference between the Oil Rent (as % of GDP) in Other small states and Oil Rent (as % of GDP) in Ghana?
Your response must be concise. 12.27. In the year 2012, what is the difference between the Oil Rent (as % of GDP) in Other small states and Oil Rent (as % of GDP) in Lithuania?
Keep it short and to the point. 18.11. In the year 2012, what is the difference between the Oil Rent (as % of GDP) in Ghana and Oil Rent (as % of GDP) in Lithuania?
Your response must be concise. 5.83. What is the ratio of the Oil Rent (as % of GDP) in Lower middle income in 2006 to that in 2007?
Provide a short and direct response. 1.16. What is the ratio of the Oil Rent (as % of GDP) in Other small states in 2006 to that in 2007?
Your answer should be very brief. 0.49. What is the ratio of the Oil Rent (as % of GDP) of Ghana in 2006 to that in 2007?
Give a very brief answer. 1.1. What is the ratio of the Oil Rent (as % of GDP) of Lithuania in 2006 to that in 2007?
Your response must be concise. 1.41. What is the ratio of the Oil Rent (as % of GDP) of Other small states in 2006 to that in 2008?
Give a very brief answer. 0.86. What is the ratio of the Oil Rent (as % of GDP) of Ghana in 2006 to that in 2008?
Your response must be concise. 0.92. What is the ratio of the Oil Rent (as % of GDP) in Lithuania in 2006 to that in 2008?
Provide a short and direct response. 1.48. What is the ratio of the Oil Rent (as % of GDP) of Lower middle income in 2006 to that in 2009?
Keep it short and to the point. 1.77. What is the ratio of the Oil Rent (as % of GDP) of Other small states in 2006 to that in 2009?
Your answer should be compact. 0.65. What is the ratio of the Oil Rent (as % of GDP) in Ghana in 2006 to that in 2009?
Make the answer very short. 1.44. What is the ratio of the Oil Rent (as % of GDP) in Lithuania in 2006 to that in 2009?
Provide a succinct answer. 2.28. What is the ratio of the Oil Rent (as % of GDP) of Lower middle income in 2006 to that in 2010?
Make the answer very short. 1.61. What is the ratio of the Oil Rent (as % of GDP) in Other small states in 2006 to that in 2010?
Your response must be concise. 0.59. What is the ratio of the Oil Rent (as % of GDP) in Ghana in 2006 to that in 2010?
Your answer should be very brief. 1.14. What is the ratio of the Oil Rent (as % of GDP) in Lithuania in 2006 to that in 2010?
Your answer should be very brief. 1.71. What is the ratio of the Oil Rent (as % of GDP) of Lower middle income in 2006 to that in 2011?
Offer a terse response. 1.41. What is the ratio of the Oil Rent (as % of GDP) in Other small states in 2006 to that in 2011?
Your answer should be very brief. 0.55. What is the ratio of the Oil Rent (as % of GDP) in Ghana in 2006 to that in 2011?
Offer a very short reply. 0.1. What is the ratio of the Oil Rent (as % of GDP) of Lithuania in 2006 to that in 2011?
Your answer should be compact. 1.5. What is the ratio of the Oil Rent (as % of GDP) of Lower middle income in 2006 to that in 2012?
Your response must be concise. 1.6. What is the ratio of the Oil Rent (as % of GDP) in Other small states in 2006 to that in 2012?
Offer a very short reply. 0.57. What is the ratio of the Oil Rent (as % of GDP) of Ghana in 2006 to that in 2012?
Offer a terse response. 0.1. What is the ratio of the Oil Rent (as % of GDP) of Lithuania in 2006 to that in 2012?
Your response must be concise. 1.7. What is the ratio of the Oil Rent (as % of GDP) of Lower middle income in 2007 to that in 2008?
Provide a succinct answer. 0.87. What is the ratio of the Oil Rent (as % of GDP) in Other small states in 2007 to that in 2008?
Offer a terse response. 1.74. What is the ratio of the Oil Rent (as % of GDP) in Ghana in 2007 to that in 2008?
Provide a succinct answer. 0.84. What is the ratio of the Oil Rent (as % of GDP) of Lithuania in 2007 to that in 2008?
Your answer should be compact. 1.05. What is the ratio of the Oil Rent (as % of GDP) in Lower middle income in 2007 to that in 2009?
Provide a short and direct response. 1.53. What is the ratio of the Oil Rent (as % of GDP) of Other small states in 2007 to that in 2009?
Ensure brevity in your answer.  1.31. What is the ratio of the Oil Rent (as % of GDP) of Ghana in 2007 to that in 2009?
Your answer should be compact. 1.31. What is the ratio of the Oil Rent (as % of GDP) in Lithuania in 2007 to that in 2009?
Offer a terse response. 1.63. What is the ratio of the Oil Rent (as % of GDP) of Lower middle income in 2007 to that in 2010?
Provide a short and direct response. 1.4. What is the ratio of the Oil Rent (as % of GDP) of Other small states in 2007 to that in 2010?
Offer a very short reply. 1.2. What is the ratio of the Oil Rent (as % of GDP) of Ghana in 2007 to that in 2010?
Make the answer very short. 1.03. What is the ratio of the Oil Rent (as % of GDP) in Lithuania in 2007 to that in 2010?
Provide a succinct answer. 1.21. What is the ratio of the Oil Rent (as % of GDP) in Lower middle income in 2007 to that in 2011?
Your answer should be compact. 1.22. What is the ratio of the Oil Rent (as % of GDP) in Other small states in 2007 to that in 2011?
Give a very brief answer. 1.12. What is the ratio of the Oil Rent (as % of GDP) in Ghana in 2007 to that in 2011?
Ensure brevity in your answer.  0.09. What is the ratio of the Oil Rent (as % of GDP) of Lithuania in 2007 to that in 2011?
Provide a short and direct response. 1.07. What is the ratio of the Oil Rent (as % of GDP) in Lower middle income in 2007 to that in 2012?
Provide a succinct answer. 1.38. What is the ratio of the Oil Rent (as % of GDP) in Other small states in 2007 to that in 2012?
Give a very brief answer. 1.15. What is the ratio of the Oil Rent (as % of GDP) of Ghana in 2007 to that in 2012?
Ensure brevity in your answer.  0.09. What is the ratio of the Oil Rent (as % of GDP) in Lithuania in 2007 to that in 2012?
Make the answer very short. 1.21. What is the ratio of the Oil Rent (as % of GDP) of Lower middle income in 2008 to that in 2009?
Provide a succinct answer. 1.77. What is the ratio of the Oil Rent (as % of GDP) in Other small states in 2008 to that in 2009?
Your response must be concise. 0.76. What is the ratio of the Oil Rent (as % of GDP) in Ghana in 2008 to that in 2009?
Your answer should be compact. 1.57. What is the ratio of the Oil Rent (as % of GDP) of Lithuania in 2008 to that in 2009?
Offer a terse response. 1.55. What is the ratio of the Oil Rent (as % of GDP) of Lower middle income in 2008 to that in 2010?
Provide a short and direct response. 1.61. What is the ratio of the Oil Rent (as % of GDP) in Other small states in 2008 to that in 2010?
Give a very brief answer. 0.69. What is the ratio of the Oil Rent (as % of GDP) of Ghana in 2008 to that in 2010?
Provide a succinct answer. 1.23. What is the ratio of the Oil Rent (as % of GDP) in Lithuania in 2008 to that in 2010?
Offer a terse response. 1.15. What is the ratio of the Oil Rent (as % of GDP) of Lower middle income in 2008 to that in 2011?
Keep it short and to the point. 1.41. What is the ratio of the Oil Rent (as % of GDP) of Other small states in 2008 to that in 2011?
Offer a terse response. 0.65. What is the ratio of the Oil Rent (as % of GDP) in Ghana in 2008 to that in 2011?
Ensure brevity in your answer.  0.11. What is the ratio of the Oil Rent (as % of GDP) of Lithuania in 2008 to that in 2011?
Provide a short and direct response. 1.02. What is the ratio of the Oil Rent (as % of GDP) in Lower middle income in 2008 to that in 2012?
Offer a terse response. 1.6. What is the ratio of the Oil Rent (as % of GDP) of Other small states in 2008 to that in 2012?
Provide a short and direct response. 0.66. What is the ratio of the Oil Rent (as % of GDP) in Ghana in 2008 to that in 2012?
Offer a very short reply. 0.11. What is the ratio of the Oil Rent (as % of GDP) of Lithuania in 2008 to that in 2012?
Make the answer very short. 1.15. What is the ratio of the Oil Rent (as % of GDP) in Lower middle income in 2009 to that in 2010?
Ensure brevity in your answer.  0.91. What is the ratio of the Oil Rent (as % of GDP) in Other small states in 2009 to that in 2010?
Your answer should be compact. 0.92. What is the ratio of the Oil Rent (as % of GDP) in Ghana in 2009 to that in 2010?
Provide a succinct answer. 0.79. What is the ratio of the Oil Rent (as % of GDP) in Lithuania in 2009 to that in 2010?
Provide a short and direct response. 0.75. What is the ratio of the Oil Rent (as % of GDP) of Lower middle income in 2009 to that in 2011?
Offer a terse response. 0.8. What is the ratio of the Oil Rent (as % of GDP) of Other small states in 2009 to that in 2011?
Ensure brevity in your answer.  0.85. What is the ratio of the Oil Rent (as % of GDP) of Ghana in 2009 to that in 2011?
Ensure brevity in your answer.  0.07. What is the ratio of the Oil Rent (as % of GDP) in Lithuania in 2009 to that in 2011?
Make the answer very short. 0.66. What is the ratio of the Oil Rent (as % of GDP) in Lower middle income in 2009 to that in 2012?
Offer a very short reply. 0.9. What is the ratio of the Oil Rent (as % of GDP) of Other small states in 2009 to that in 2012?
Make the answer very short. 0.87. What is the ratio of the Oil Rent (as % of GDP) in Ghana in 2009 to that in 2012?
Your response must be concise. 0.07. What is the ratio of the Oil Rent (as % of GDP) of Lithuania in 2009 to that in 2012?
Provide a succinct answer. 0.74. What is the ratio of the Oil Rent (as % of GDP) of Lower middle income in 2010 to that in 2011?
Ensure brevity in your answer.  0.88. What is the ratio of the Oil Rent (as % of GDP) in Other small states in 2010 to that in 2011?
Ensure brevity in your answer.  0.93. What is the ratio of the Oil Rent (as % of GDP) of Ghana in 2010 to that in 2011?
Offer a very short reply. 0.09. What is the ratio of the Oil Rent (as % of GDP) of Lithuania in 2010 to that in 2011?
Give a very brief answer. 0.88. What is the ratio of the Oil Rent (as % of GDP) of Other small states in 2010 to that in 2012?
Offer a very short reply. 0.95. What is the ratio of the Oil Rent (as % of GDP) of Ghana in 2010 to that in 2012?
Offer a very short reply. 0.09. What is the ratio of the Oil Rent (as % of GDP) in Lower middle income in 2011 to that in 2012?
Your answer should be very brief. 1.13. What is the ratio of the Oil Rent (as % of GDP) in Other small states in 2011 to that in 2012?
Keep it short and to the point. 1.02. What is the ratio of the Oil Rent (as % of GDP) in Ghana in 2011 to that in 2012?
Give a very brief answer. 1.05. What is the ratio of the Oil Rent (as % of GDP) in Lithuania in 2011 to that in 2012?
Provide a short and direct response. 1.13. What is the difference between the highest and the second highest Oil Rent (as % of GDP) of Lower middle income?
Provide a short and direct response. 0.01. What is the difference between the highest and the second highest Oil Rent (as % of GDP) of Other small states?
Provide a short and direct response. 2.25. What is the difference between the highest and the second highest Oil Rent (as % of GDP) in Lithuania?
Provide a short and direct response. 0.07. What is the difference between the highest and the lowest Oil Rent (as % of GDP) in Lower middle income?
Provide a short and direct response. 2.5. What is the difference between the highest and the lowest Oil Rent (as % of GDP) in Other small states?
Ensure brevity in your answer.  10.6. What is the difference between the highest and the lowest Oil Rent (as % of GDP) of Ghana?
Your answer should be very brief. 5.85. What is the difference between the highest and the lowest Oil Rent (as % of GDP) of Lithuania?
Your response must be concise. 0.14. 